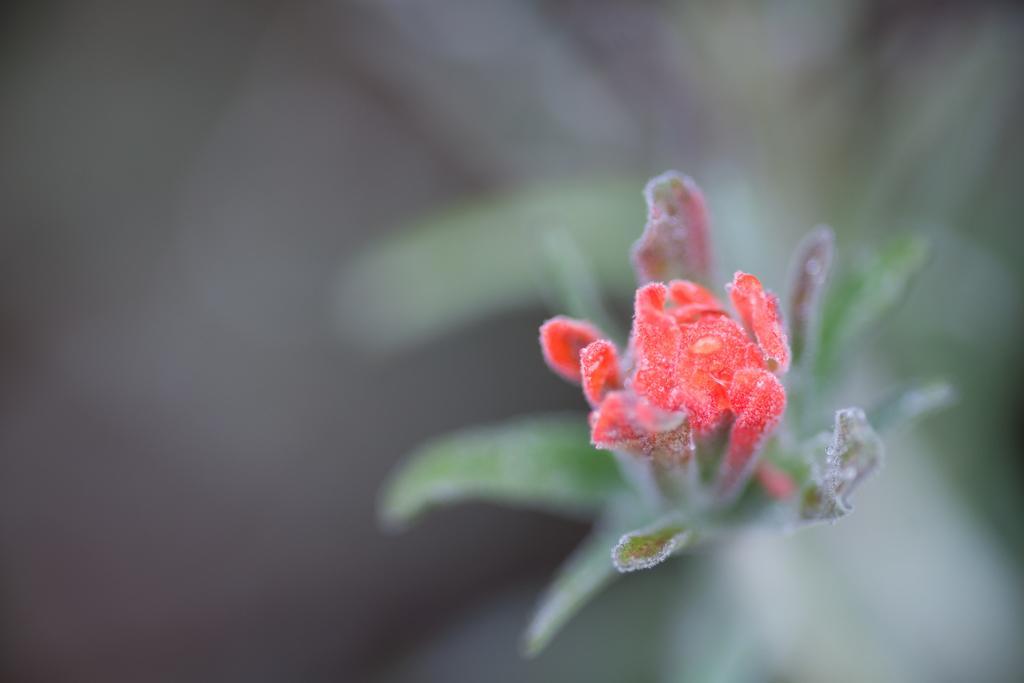Could you give a brief overview of what you see in this image? In the center of the image we can see leaves and one flower, which is in red color. 